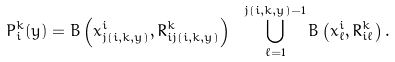<formula> <loc_0><loc_0><loc_500><loc_500>P _ { i } ^ { k } ( y ) = B \left ( x ^ { i } _ { j ( i , k , y ) } , R ^ { k } _ { i j ( i , k , y ) } \right ) \ \bigcup _ { \ell = 1 } ^ { j ( i , k , y ) - 1 } B \left ( x ^ { i } _ { \ell } , R ^ { k } _ { i \ell } \right ) .</formula> 